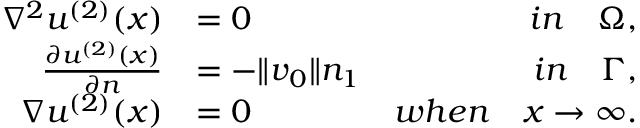Convert formula to latex. <formula><loc_0><loc_0><loc_500><loc_500>\begin{array} { r l r } { \nabla ^ { 2 } u ^ { ( 2 ) } ( x ) } & { = 0 } & { i n \quad \Omega , } \\ { \frac { \partial u ^ { ( 2 ) } ( x ) } { \partial n } } & { = - \| v _ { 0 } \| n _ { 1 } } & { i n \quad \Gamma , } \\ { \nabla u ^ { ( 2 ) } ( x ) } & { = 0 } & { w h e n \quad x \rightarrow \infty . } \end{array}</formula> 